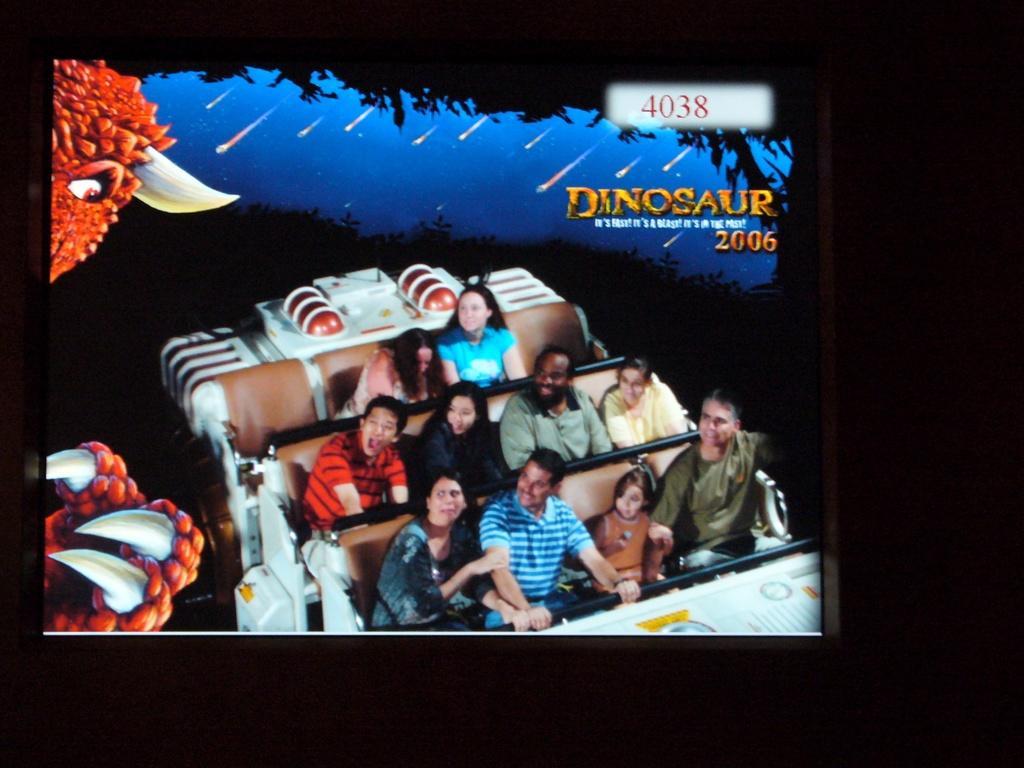Please provide a concise description of this image. In the middle there are group of people sitting on the seats in a vehicle. In the left bird of orange color is half visible. On the top sky visible of blue in color. On both side the background is dark in color. On the top a text is there. This image is an edited photo taken. 